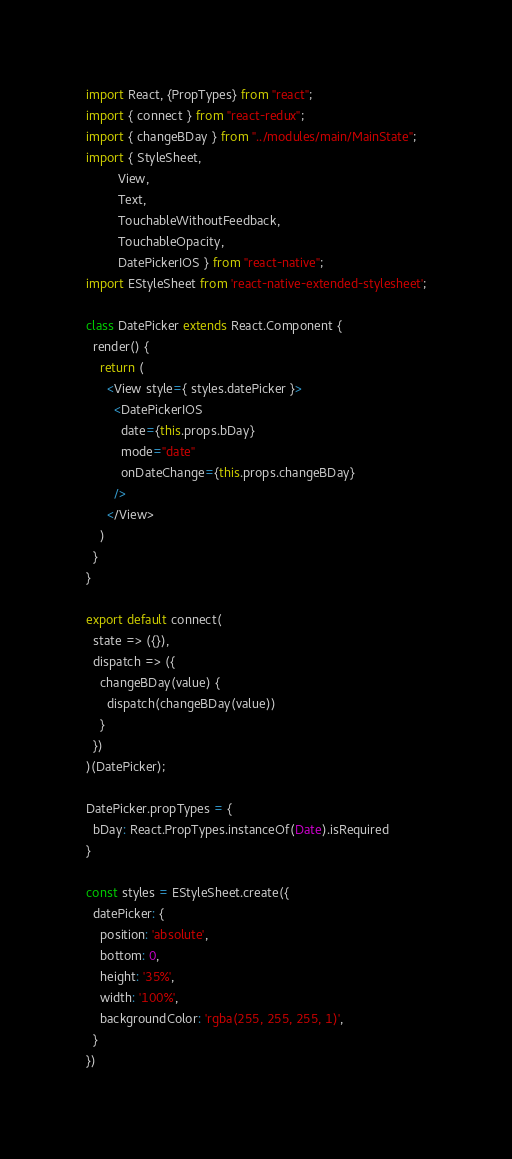Convert code to text. <code><loc_0><loc_0><loc_500><loc_500><_JavaScript_>import React, {PropTypes} from "react";
import { connect } from "react-redux";
import { changeBDay } from "../modules/main/MainState";
import { StyleSheet,
         View,
         Text,
         TouchableWithoutFeedback,
         TouchableOpacity,
         DatePickerIOS } from "react-native";
import EStyleSheet from 'react-native-extended-stylesheet';

class DatePicker extends React.Component {
  render() {
    return (
      <View style={ styles.datePicker }>
        <DatePickerIOS
          date={this.props.bDay}
          mode="date"
          onDateChange={this.props.changeBDay}
        />
      </View>
    )
  }
}

export default connect(
  state => ({}),
  dispatch => ({
    changeBDay(value) {
      dispatch(changeBDay(value))
    }
  })
)(DatePicker);

DatePicker.propTypes = {
  bDay: React.PropTypes.instanceOf(Date).isRequired
}

const styles = EStyleSheet.create({
  datePicker: {
    position: 'absolute',
    bottom: 0,
    height: '35%',
    width: '100%',
    backgroundColor: 'rgba(255, 255, 255, 1)',    
  }
})</code> 